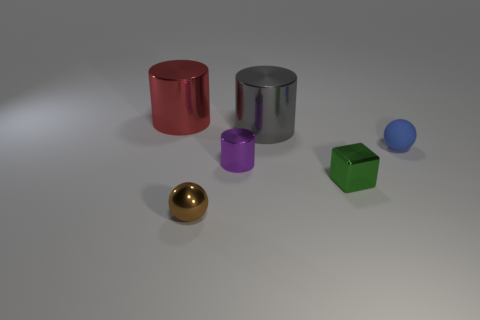Is the matte sphere the same size as the green object?
Your answer should be compact. Yes. What shape is the big gray object that is the same material as the small brown sphere?
Ensure brevity in your answer.  Cylinder. How many other things are there of the same shape as the rubber object?
Your answer should be very brief. 1. There is a metallic thing on the right side of the gray shiny thing to the right of the tiny purple metallic thing that is in front of the tiny blue matte ball; what shape is it?
Your response must be concise. Cube. How many cubes are either green things or big things?
Your response must be concise. 1. There is a large cylinder right of the large red object; is there a small object that is to the right of it?
Make the answer very short. Yes. Is there anything else that is the same material as the blue sphere?
Provide a succinct answer. No. Does the small purple thing have the same shape as the large metallic thing to the right of the brown metal ball?
Your answer should be compact. Yes. How many other things are the same size as the red cylinder?
Your answer should be very brief. 1. How many purple objects are either small metallic cylinders or metal cylinders?
Offer a terse response. 1. 